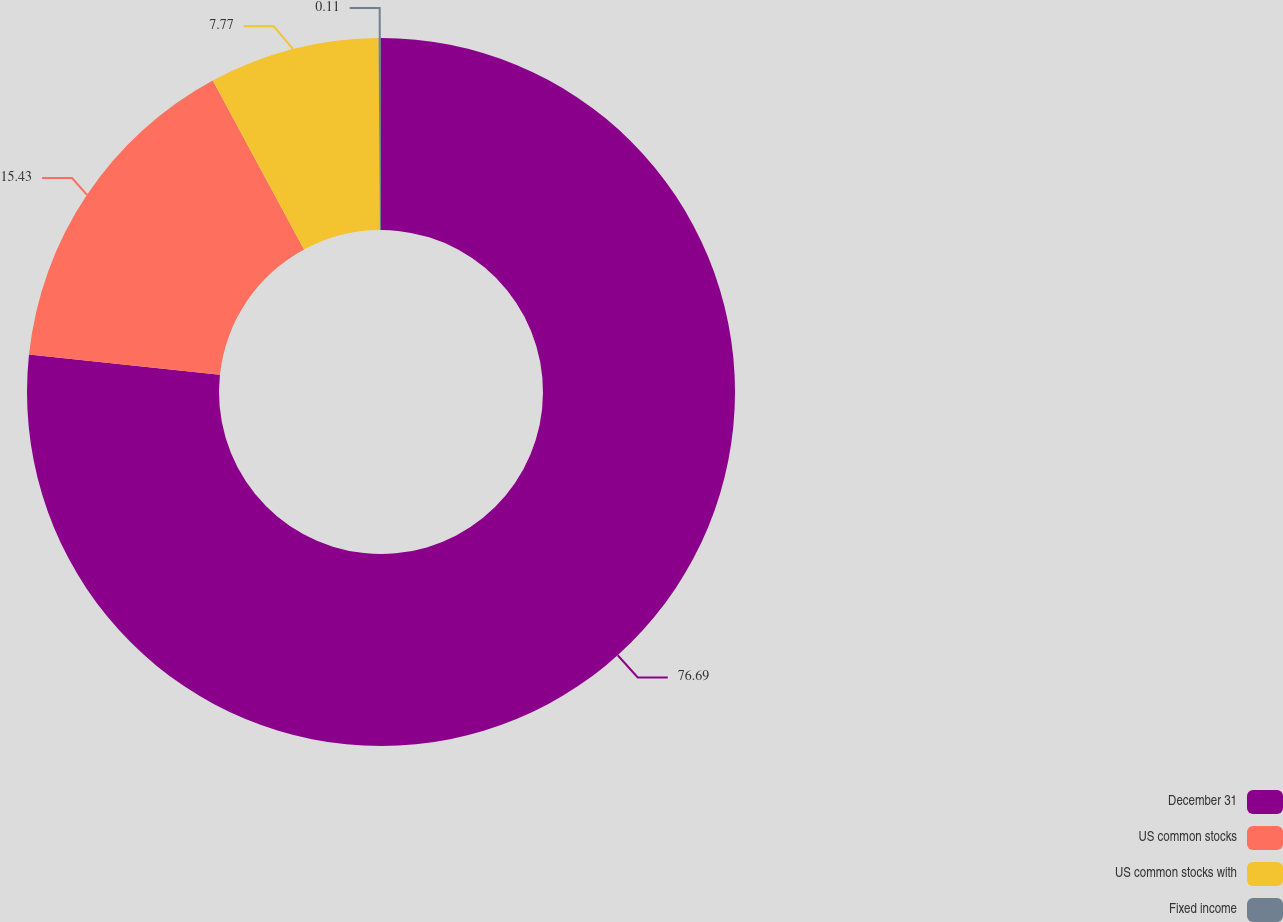Convert chart to OTSL. <chart><loc_0><loc_0><loc_500><loc_500><pie_chart><fcel>December 31<fcel>US common stocks<fcel>US common stocks with<fcel>Fixed income<nl><fcel>76.68%<fcel>15.43%<fcel>7.77%<fcel>0.11%<nl></chart> 